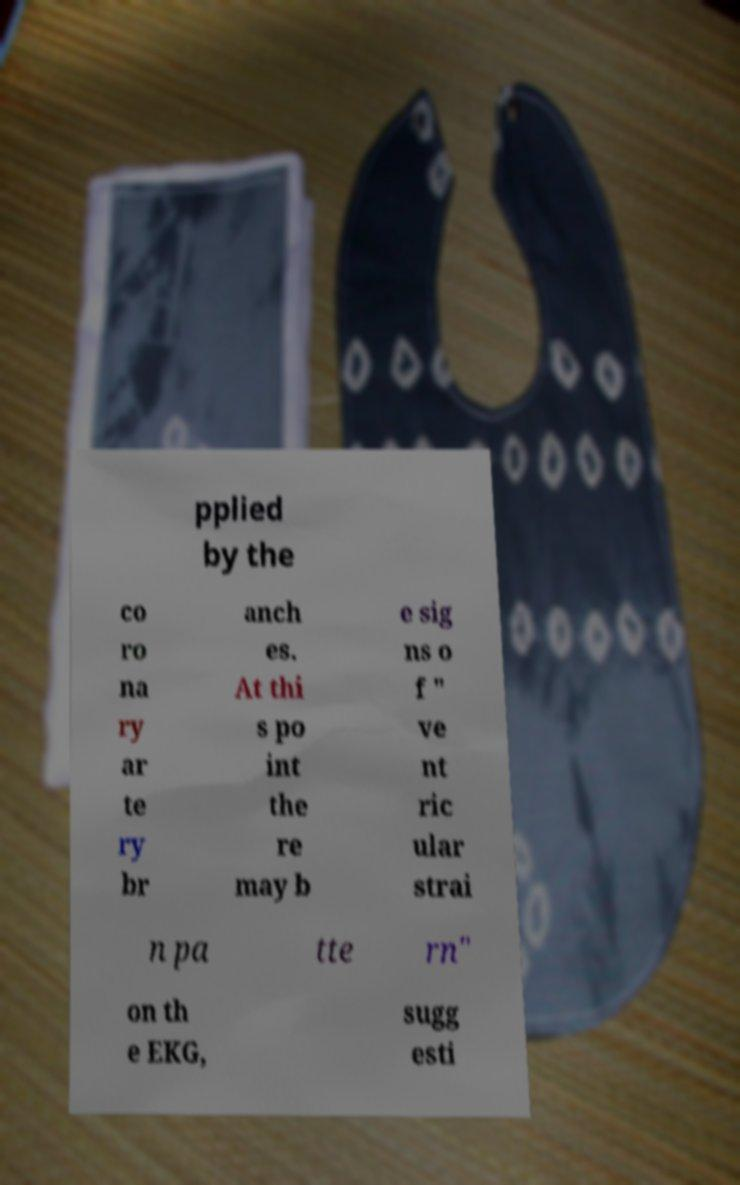For documentation purposes, I need the text within this image transcribed. Could you provide that? pplied by the co ro na ry ar te ry br anch es. At thi s po int the re may b e sig ns o f " ve nt ric ular strai n pa tte rn" on th e EKG, sugg esti 